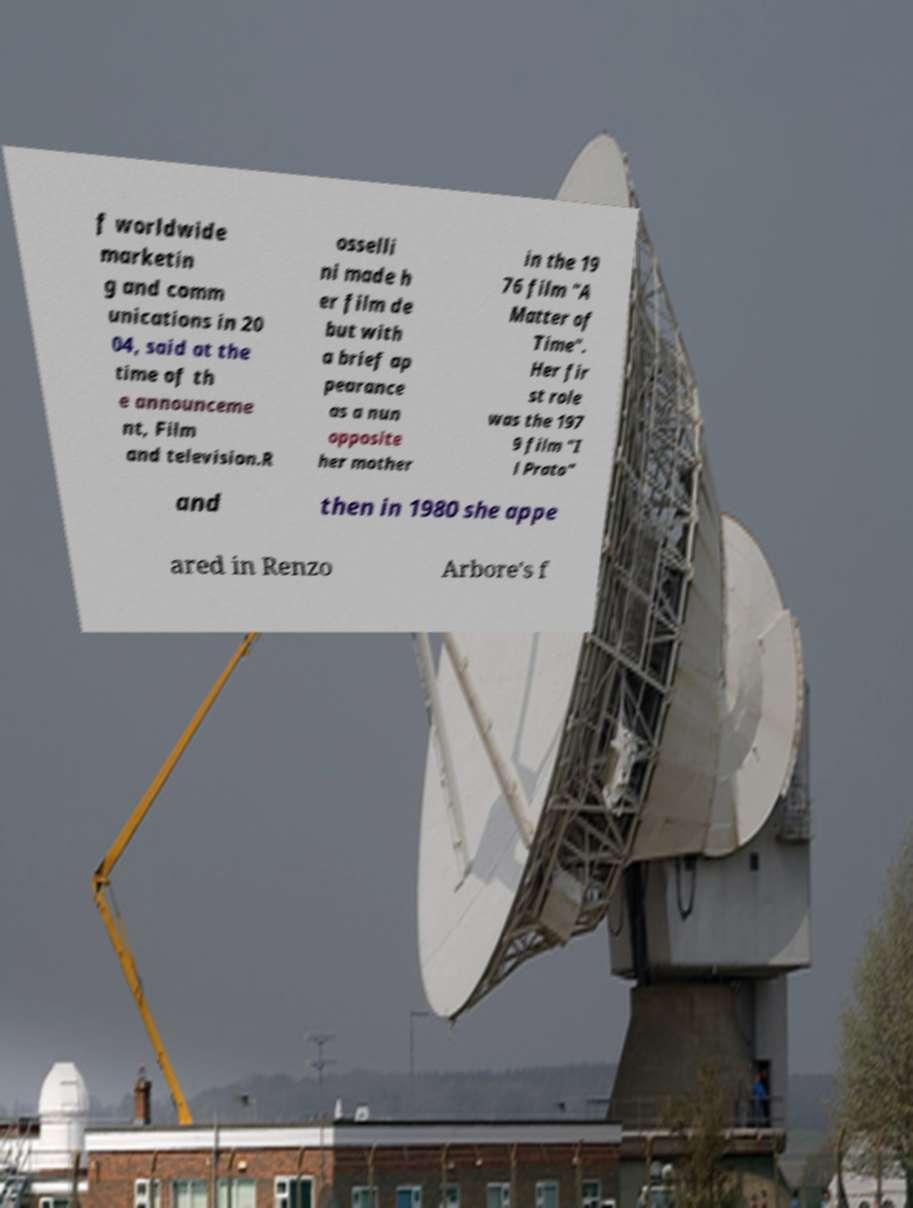Could you assist in decoding the text presented in this image and type it out clearly? f worldwide marketin g and comm unications in 20 04, said at the time of th e announceme nt, Film and television.R osselli ni made h er film de but with a brief ap pearance as a nun opposite her mother in the 19 76 film "A Matter of Time". Her fir st role was the 197 9 film "I l Prato" and then in 1980 she appe ared in Renzo Arbore's f 